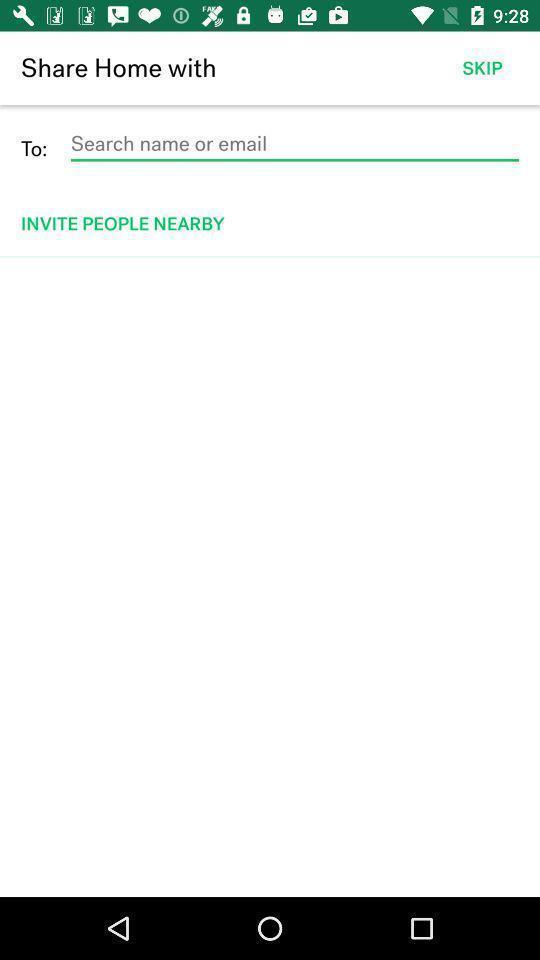Tell me about the visual elements in this screen capture. Search page to find name or email. 